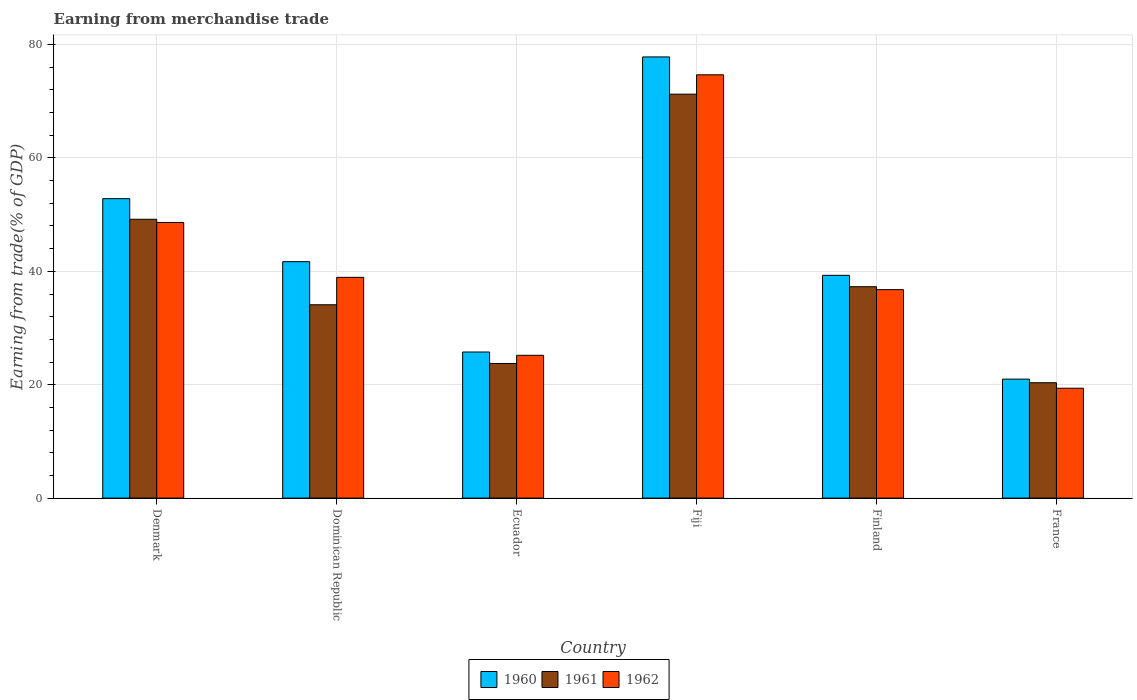How many different coloured bars are there?
Make the answer very short. 3. Are the number of bars per tick equal to the number of legend labels?
Provide a succinct answer. Yes. Are the number of bars on each tick of the X-axis equal?
Offer a terse response. Yes. How many bars are there on the 4th tick from the left?
Provide a short and direct response. 3. What is the label of the 5th group of bars from the left?
Offer a terse response. Finland. In how many cases, is the number of bars for a given country not equal to the number of legend labels?
Offer a very short reply. 0. What is the earnings from trade in 1962 in Fiji?
Offer a very short reply. 74.67. Across all countries, what is the maximum earnings from trade in 1961?
Offer a terse response. 71.25. Across all countries, what is the minimum earnings from trade in 1961?
Your response must be concise. 20.35. In which country was the earnings from trade in 1960 maximum?
Keep it short and to the point. Fiji. In which country was the earnings from trade in 1961 minimum?
Offer a very short reply. France. What is the total earnings from trade in 1961 in the graph?
Make the answer very short. 235.93. What is the difference between the earnings from trade in 1962 in Dominican Republic and that in Fiji?
Offer a terse response. -35.73. What is the difference between the earnings from trade in 1962 in Fiji and the earnings from trade in 1961 in Denmark?
Give a very brief answer. 25.48. What is the average earnings from trade in 1962 per country?
Your answer should be very brief. 40.59. What is the difference between the earnings from trade of/in 1960 and earnings from trade of/in 1961 in France?
Your answer should be compact. 0.64. What is the ratio of the earnings from trade in 1961 in Fiji to that in Finland?
Keep it short and to the point. 1.91. Is the earnings from trade in 1962 in Denmark less than that in Finland?
Provide a succinct answer. No. Is the difference between the earnings from trade in 1960 in Denmark and France greater than the difference between the earnings from trade in 1961 in Denmark and France?
Ensure brevity in your answer.  Yes. What is the difference between the highest and the second highest earnings from trade in 1960?
Give a very brief answer. -11.11. What is the difference between the highest and the lowest earnings from trade in 1960?
Give a very brief answer. 56.83. In how many countries, is the earnings from trade in 1960 greater than the average earnings from trade in 1960 taken over all countries?
Your response must be concise. 2. Is the sum of the earnings from trade in 1960 in Denmark and Fiji greater than the maximum earnings from trade in 1962 across all countries?
Provide a succinct answer. Yes. What does the 1st bar from the right in Ecuador represents?
Make the answer very short. 1962. How many bars are there?
Provide a succinct answer. 18. What is the difference between two consecutive major ticks on the Y-axis?
Provide a succinct answer. 20. Are the values on the major ticks of Y-axis written in scientific E-notation?
Your response must be concise. No. Does the graph contain any zero values?
Keep it short and to the point. No. Does the graph contain grids?
Your answer should be compact. Yes. How are the legend labels stacked?
Your answer should be compact. Horizontal. What is the title of the graph?
Offer a very short reply. Earning from merchandise trade. Does "1987" appear as one of the legend labels in the graph?
Make the answer very short. No. What is the label or title of the Y-axis?
Your answer should be compact. Earning from trade(% of GDP). What is the Earning from trade(% of GDP) in 1960 in Denmark?
Offer a very short reply. 52.82. What is the Earning from trade(% of GDP) of 1961 in Denmark?
Your answer should be very brief. 49.19. What is the Earning from trade(% of GDP) of 1962 in Denmark?
Offer a very short reply. 48.62. What is the Earning from trade(% of GDP) in 1960 in Dominican Republic?
Your response must be concise. 41.7. What is the Earning from trade(% of GDP) in 1961 in Dominican Republic?
Provide a short and direct response. 34.1. What is the Earning from trade(% of GDP) in 1962 in Dominican Republic?
Provide a succinct answer. 38.94. What is the Earning from trade(% of GDP) of 1960 in Ecuador?
Offer a very short reply. 25.77. What is the Earning from trade(% of GDP) in 1961 in Ecuador?
Ensure brevity in your answer.  23.75. What is the Earning from trade(% of GDP) in 1962 in Ecuador?
Offer a very short reply. 25.19. What is the Earning from trade(% of GDP) in 1960 in Fiji?
Your answer should be compact. 77.82. What is the Earning from trade(% of GDP) of 1961 in Fiji?
Your answer should be compact. 71.25. What is the Earning from trade(% of GDP) in 1962 in Fiji?
Your answer should be very brief. 74.67. What is the Earning from trade(% of GDP) of 1960 in Finland?
Ensure brevity in your answer.  39.29. What is the Earning from trade(% of GDP) in 1961 in Finland?
Give a very brief answer. 37.29. What is the Earning from trade(% of GDP) in 1962 in Finland?
Make the answer very short. 36.77. What is the Earning from trade(% of GDP) in 1960 in France?
Your answer should be compact. 20.99. What is the Earning from trade(% of GDP) of 1961 in France?
Give a very brief answer. 20.35. What is the Earning from trade(% of GDP) in 1962 in France?
Provide a succinct answer. 19.38. Across all countries, what is the maximum Earning from trade(% of GDP) in 1960?
Your answer should be very brief. 77.82. Across all countries, what is the maximum Earning from trade(% of GDP) in 1961?
Offer a very short reply. 71.25. Across all countries, what is the maximum Earning from trade(% of GDP) in 1962?
Ensure brevity in your answer.  74.67. Across all countries, what is the minimum Earning from trade(% of GDP) in 1960?
Keep it short and to the point. 20.99. Across all countries, what is the minimum Earning from trade(% of GDP) in 1961?
Make the answer very short. 20.35. Across all countries, what is the minimum Earning from trade(% of GDP) in 1962?
Provide a succinct answer. 19.38. What is the total Earning from trade(% of GDP) in 1960 in the graph?
Provide a short and direct response. 258.39. What is the total Earning from trade(% of GDP) of 1961 in the graph?
Give a very brief answer. 235.93. What is the total Earning from trade(% of GDP) of 1962 in the graph?
Offer a very short reply. 243.57. What is the difference between the Earning from trade(% of GDP) of 1960 in Denmark and that in Dominican Republic?
Offer a very short reply. 11.11. What is the difference between the Earning from trade(% of GDP) in 1961 in Denmark and that in Dominican Republic?
Your answer should be very brief. 15.08. What is the difference between the Earning from trade(% of GDP) of 1962 in Denmark and that in Dominican Republic?
Make the answer very short. 9.68. What is the difference between the Earning from trade(% of GDP) in 1960 in Denmark and that in Ecuador?
Ensure brevity in your answer.  27.05. What is the difference between the Earning from trade(% of GDP) in 1961 in Denmark and that in Ecuador?
Offer a terse response. 25.44. What is the difference between the Earning from trade(% of GDP) of 1962 in Denmark and that in Ecuador?
Give a very brief answer. 23.44. What is the difference between the Earning from trade(% of GDP) of 1960 in Denmark and that in Fiji?
Provide a succinct answer. -25. What is the difference between the Earning from trade(% of GDP) in 1961 in Denmark and that in Fiji?
Offer a terse response. -22.07. What is the difference between the Earning from trade(% of GDP) of 1962 in Denmark and that in Fiji?
Give a very brief answer. -26.05. What is the difference between the Earning from trade(% of GDP) of 1960 in Denmark and that in Finland?
Ensure brevity in your answer.  13.52. What is the difference between the Earning from trade(% of GDP) in 1961 in Denmark and that in Finland?
Offer a very short reply. 11.9. What is the difference between the Earning from trade(% of GDP) of 1962 in Denmark and that in Finland?
Make the answer very short. 11.85. What is the difference between the Earning from trade(% of GDP) of 1960 in Denmark and that in France?
Ensure brevity in your answer.  31.83. What is the difference between the Earning from trade(% of GDP) of 1961 in Denmark and that in France?
Keep it short and to the point. 28.84. What is the difference between the Earning from trade(% of GDP) in 1962 in Denmark and that in France?
Offer a terse response. 29.24. What is the difference between the Earning from trade(% of GDP) in 1960 in Dominican Republic and that in Ecuador?
Make the answer very short. 15.94. What is the difference between the Earning from trade(% of GDP) in 1961 in Dominican Republic and that in Ecuador?
Make the answer very short. 10.36. What is the difference between the Earning from trade(% of GDP) in 1962 in Dominican Republic and that in Ecuador?
Offer a very short reply. 13.75. What is the difference between the Earning from trade(% of GDP) of 1960 in Dominican Republic and that in Fiji?
Offer a very short reply. -36.12. What is the difference between the Earning from trade(% of GDP) in 1961 in Dominican Republic and that in Fiji?
Give a very brief answer. -37.15. What is the difference between the Earning from trade(% of GDP) of 1962 in Dominican Republic and that in Fiji?
Offer a terse response. -35.73. What is the difference between the Earning from trade(% of GDP) in 1960 in Dominican Republic and that in Finland?
Provide a succinct answer. 2.41. What is the difference between the Earning from trade(% of GDP) of 1961 in Dominican Republic and that in Finland?
Your response must be concise. -3.19. What is the difference between the Earning from trade(% of GDP) in 1962 in Dominican Republic and that in Finland?
Your answer should be very brief. 2.17. What is the difference between the Earning from trade(% of GDP) in 1960 in Dominican Republic and that in France?
Provide a succinct answer. 20.72. What is the difference between the Earning from trade(% of GDP) in 1961 in Dominican Republic and that in France?
Provide a short and direct response. 13.76. What is the difference between the Earning from trade(% of GDP) of 1962 in Dominican Republic and that in France?
Provide a succinct answer. 19.56. What is the difference between the Earning from trade(% of GDP) of 1960 in Ecuador and that in Fiji?
Your answer should be very brief. -52.05. What is the difference between the Earning from trade(% of GDP) in 1961 in Ecuador and that in Fiji?
Your answer should be compact. -47.51. What is the difference between the Earning from trade(% of GDP) of 1962 in Ecuador and that in Fiji?
Your answer should be very brief. -49.48. What is the difference between the Earning from trade(% of GDP) of 1960 in Ecuador and that in Finland?
Offer a very short reply. -13.53. What is the difference between the Earning from trade(% of GDP) in 1961 in Ecuador and that in Finland?
Offer a very short reply. -13.54. What is the difference between the Earning from trade(% of GDP) in 1962 in Ecuador and that in Finland?
Your answer should be compact. -11.59. What is the difference between the Earning from trade(% of GDP) of 1960 in Ecuador and that in France?
Give a very brief answer. 4.78. What is the difference between the Earning from trade(% of GDP) of 1961 in Ecuador and that in France?
Your answer should be compact. 3.4. What is the difference between the Earning from trade(% of GDP) of 1962 in Ecuador and that in France?
Your answer should be compact. 5.81. What is the difference between the Earning from trade(% of GDP) in 1960 in Fiji and that in Finland?
Offer a very short reply. 38.52. What is the difference between the Earning from trade(% of GDP) in 1961 in Fiji and that in Finland?
Give a very brief answer. 33.96. What is the difference between the Earning from trade(% of GDP) of 1962 in Fiji and that in Finland?
Provide a succinct answer. 37.9. What is the difference between the Earning from trade(% of GDP) of 1960 in Fiji and that in France?
Make the answer very short. 56.83. What is the difference between the Earning from trade(% of GDP) of 1961 in Fiji and that in France?
Offer a very short reply. 50.91. What is the difference between the Earning from trade(% of GDP) of 1962 in Fiji and that in France?
Your answer should be very brief. 55.29. What is the difference between the Earning from trade(% of GDP) of 1960 in Finland and that in France?
Your answer should be very brief. 18.31. What is the difference between the Earning from trade(% of GDP) in 1961 in Finland and that in France?
Give a very brief answer. 16.94. What is the difference between the Earning from trade(% of GDP) in 1962 in Finland and that in France?
Provide a short and direct response. 17.39. What is the difference between the Earning from trade(% of GDP) of 1960 in Denmark and the Earning from trade(% of GDP) of 1961 in Dominican Republic?
Provide a short and direct response. 18.72. What is the difference between the Earning from trade(% of GDP) of 1960 in Denmark and the Earning from trade(% of GDP) of 1962 in Dominican Republic?
Provide a succinct answer. 13.88. What is the difference between the Earning from trade(% of GDP) of 1961 in Denmark and the Earning from trade(% of GDP) of 1962 in Dominican Republic?
Make the answer very short. 10.25. What is the difference between the Earning from trade(% of GDP) in 1960 in Denmark and the Earning from trade(% of GDP) in 1961 in Ecuador?
Offer a very short reply. 29.07. What is the difference between the Earning from trade(% of GDP) in 1960 in Denmark and the Earning from trade(% of GDP) in 1962 in Ecuador?
Offer a very short reply. 27.63. What is the difference between the Earning from trade(% of GDP) of 1961 in Denmark and the Earning from trade(% of GDP) of 1962 in Ecuador?
Your answer should be very brief. 24. What is the difference between the Earning from trade(% of GDP) in 1960 in Denmark and the Earning from trade(% of GDP) in 1961 in Fiji?
Provide a succinct answer. -18.43. What is the difference between the Earning from trade(% of GDP) of 1960 in Denmark and the Earning from trade(% of GDP) of 1962 in Fiji?
Provide a short and direct response. -21.85. What is the difference between the Earning from trade(% of GDP) in 1961 in Denmark and the Earning from trade(% of GDP) in 1962 in Fiji?
Keep it short and to the point. -25.48. What is the difference between the Earning from trade(% of GDP) of 1960 in Denmark and the Earning from trade(% of GDP) of 1961 in Finland?
Provide a succinct answer. 15.53. What is the difference between the Earning from trade(% of GDP) in 1960 in Denmark and the Earning from trade(% of GDP) in 1962 in Finland?
Ensure brevity in your answer.  16.05. What is the difference between the Earning from trade(% of GDP) of 1961 in Denmark and the Earning from trade(% of GDP) of 1962 in Finland?
Give a very brief answer. 12.41. What is the difference between the Earning from trade(% of GDP) of 1960 in Denmark and the Earning from trade(% of GDP) of 1961 in France?
Make the answer very short. 32.47. What is the difference between the Earning from trade(% of GDP) of 1960 in Denmark and the Earning from trade(% of GDP) of 1962 in France?
Your answer should be compact. 33.44. What is the difference between the Earning from trade(% of GDP) in 1961 in Denmark and the Earning from trade(% of GDP) in 1962 in France?
Provide a short and direct response. 29.81. What is the difference between the Earning from trade(% of GDP) in 1960 in Dominican Republic and the Earning from trade(% of GDP) in 1961 in Ecuador?
Make the answer very short. 17.96. What is the difference between the Earning from trade(% of GDP) in 1960 in Dominican Republic and the Earning from trade(% of GDP) in 1962 in Ecuador?
Your answer should be very brief. 16.52. What is the difference between the Earning from trade(% of GDP) of 1961 in Dominican Republic and the Earning from trade(% of GDP) of 1962 in Ecuador?
Keep it short and to the point. 8.92. What is the difference between the Earning from trade(% of GDP) of 1960 in Dominican Republic and the Earning from trade(% of GDP) of 1961 in Fiji?
Your answer should be compact. -29.55. What is the difference between the Earning from trade(% of GDP) in 1960 in Dominican Republic and the Earning from trade(% of GDP) in 1962 in Fiji?
Provide a succinct answer. -32.96. What is the difference between the Earning from trade(% of GDP) in 1961 in Dominican Republic and the Earning from trade(% of GDP) in 1962 in Fiji?
Give a very brief answer. -40.57. What is the difference between the Earning from trade(% of GDP) of 1960 in Dominican Republic and the Earning from trade(% of GDP) of 1961 in Finland?
Your response must be concise. 4.42. What is the difference between the Earning from trade(% of GDP) of 1960 in Dominican Republic and the Earning from trade(% of GDP) of 1962 in Finland?
Give a very brief answer. 4.93. What is the difference between the Earning from trade(% of GDP) in 1961 in Dominican Republic and the Earning from trade(% of GDP) in 1962 in Finland?
Give a very brief answer. -2.67. What is the difference between the Earning from trade(% of GDP) in 1960 in Dominican Republic and the Earning from trade(% of GDP) in 1961 in France?
Provide a succinct answer. 21.36. What is the difference between the Earning from trade(% of GDP) of 1960 in Dominican Republic and the Earning from trade(% of GDP) of 1962 in France?
Ensure brevity in your answer.  22.32. What is the difference between the Earning from trade(% of GDP) in 1961 in Dominican Republic and the Earning from trade(% of GDP) in 1962 in France?
Provide a succinct answer. 14.72. What is the difference between the Earning from trade(% of GDP) in 1960 in Ecuador and the Earning from trade(% of GDP) in 1961 in Fiji?
Offer a terse response. -45.48. What is the difference between the Earning from trade(% of GDP) in 1960 in Ecuador and the Earning from trade(% of GDP) in 1962 in Fiji?
Your answer should be very brief. -48.9. What is the difference between the Earning from trade(% of GDP) in 1961 in Ecuador and the Earning from trade(% of GDP) in 1962 in Fiji?
Your answer should be compact. -50.92. What is the difference between the Earning from trade(% of GDP) in 1960 in Ecuador and the Earning from trade(% of GDP) in 1961 in Finland?
Your answer should be compact. -11.52. What is the difference between the Earning from trade(% of GDP) in 1960 in Ecuador and the Earning from trade(% of GDP) in 1962 in Finland?
Ensure brevity in your answer.  -11. What is the difference between the Earning from trade(% of GDP) in 1961 in Ecuador and the Earning from trade(% of GDP) in 1962 in Finland?
Provide a succinct answer. -13.02. What is the difference between the Earning from trade(% of GDP) of 1960 in Ecuador and the Earning from trade(% of GDP) of 1961 in France?
Your answer should be compact. 5.42. What is the difference between the Earning from trade(% of GDP) of 1960 in Ecuador and the Earning from trade(% of GDP) of 1962 in France?
Your answer should be very brief. 6.39. What is the difference between the Earning from trade(% of GDP) in 1961 in Ecuador and the Earning from trade(% of GDP) in 1962 in France?
Ensure brevity in your answer.  4.37. What is the difference between the Earning from trade(% of GDP) of 1960 in Fiji and the Earning from trade(% of GDP) of 1961 in Finland?
Your answer should be very brief. 40.53. What is the difference between the Earning from trade(% of GDP) in 1960 in Fiji and the Earning from trade(% of GDP) in 1962 in Finland?
Your answer should be compact. 41.05. What is the difference between the Earning from trade(% of GDP) of 1961 in Fiji and the Earning from trade(% of GDP) of 1962 in Finland?
Provide a succinct answer. 34.48. What is the difference between the Earning from trade(% of GDP) in 1960 in Fiji and the Earning from trade(% of GDP) in 1961 in France?
Ensure brevity in your answer.  57.47. What is the difference between the Earning from trade(% of GDP) of 1960 in Fiji and the Earning from trade(% of GDP) of 1962 in France?
Your answer should be very brief. 58.44. What is the difference between the Earning from trade(% of GDP) of 1961 in Fiji and the Earning from trade(% of GDP) of 1962 in France?
Keep it short and to the point. 51.87. What is the difference between the Earning from trade(% of GDP) in 1960 in Finland and the Earning from trade(% of GDP) in 1961 in France?
Ensure brevity in your answer.  18.95. What is the difference between the Earning from trade(% of GDP) in 1960 in Finland and the Earning from trade(% of GDP) in 1962 in France?
Your answer should be compact. 19.91. What is the difference between the Earning from trade(% of GDP) in 1961 in Finland and the Earning from trade(% of GDP) in 1962 in France?
Keep it short and to the point. 17.91. What is the average Earning from trade(% of GDP) in 1960 per country?
Offer a very short reply. 43.07. What is the average Earning from trade(% of GDP) in 1961 per country?
Provide a short and direct response. 39.32. What is the average Earning from trade(% of GDP) in 1962 per country?
Your response must be concise. 40.59. What is the difference between the Earning from trade(% of GDP) in 1960 and Earning from trade(% of GDP) in 1961 in Denmark?
Provide a succinct answer. 3.63. What is the difference between the Earning from trade(% of GDP) in 1960 and Earning from trade(% of GDP) in 1962 in Denmark?
Give a very brief answer. 4.2. What is the difference between the Earning from trade(% of GDP) of 1961 and Earning from trade(% of GDP) of 1962 in Denmark?
Your answer should be compact. 0.56. What is the difference between the Earning from trade(% of GDP) of 1960 and Earning from trade(% of GDP) of 1961 in Dominican Republic?
Provide a short and direct response. 7.6. What is the difference between the Earning from trade(% of GDP) in 1960 and Earning from trade(% of GDP) in 1962 in Dominican Republic?
Offer a very short reply. 2.77. What is the difference between the Earning from trade(% of GDP) in 1961 and Earning from trade(% of GDP) in 1962 in Dominican Republic?
Give a very brief answer. -4.84. What is the difference between the Earning from trade(% of GDP) of 1960 and Earning from trade(% of GDP) of 1961 in Ecuador?
Make the answer very short. 2.02. What is the difference between the Earning from trade(% of GDP) in 1960 and Earning from trade(% of GDP) in 1962 in Ecuador?
Make the answer very short. 0.58. What is the difference between the Earning from trade(% of GDP) of 1961 and Earning from trade(% of GDP) of 1962 in Ecuador?
Provide a short and direct response. -1.44. What is the difference between the Earning from trade(% of GDP) in 1960 and Earning from trade(% of GDP) in 1961 in Fiji?
Provide a short and direct response. 6.57. What is the difference between the Earning from trade(% of GDP) of 1960 and Earning from trade(% of GDP) of 1962 in Fiji?
Your answer should be compact. 3.15. What is the difference between the Earning from trade(% of GDP) in 1961 and Earning from trade(% of GDP) in 1962 in Fiji?
Offer a very short reply. -3.42. What is the difference between the Earning from trade(% of GDP) of 1960 and Earning from trade(% of GDP) of 1961 in Finland?
Offer a terse response. 2.01. What is the difference between the Earning from trade(% of GDP) in 1960 and Earning from trade(% of GDP) in 1962 in Finland?
Your answer should be compact. 2.52. What is the difference between the Earning from trade(% of GDP) in 1961 and Earning from trade(% of GDP) in 1962 in Finland?
Provide a succinct answer. 0.52. What is the difference between the Earning from trade(% of GDP) in 1960 and Earning from trade(% of GDP) in 1961 in France?
Your answer should be very brief. 0.64. What is the difference between the Earning from trade(% of GDP) in 1960 and Earning from trade(% of GDP) in 1962 in France?
Your answer should be very brief. 1.61. What is the difference between the Earning from trade(% of GDP) in 1961 and Earning from trade(% of GDP) in 1962 in France?
Give a very brief answer. 0.97. What is the ratio of the Earning from trade(% of GDP) in 1960 in Denmark to that in Dominican Republic?
Your answer should be compact. 1.27. What is the ratio of the Earning from trade(% of GDP) in 1961 in Denmark to that in Dominican Republic?
Provide a succinct answer. 1.44. What is the ratio of the Earning from trade(% of GDP) of 1962 in Denmark to that in Dominican Republic?
Give a very brief answer. 1.25. What is the ratio of the Earning from trade(% of GDP) in 1960 in Denmark to that in Ecuador?
Offer a terse response. 2.05. What is the ratio of the Earning from trade(% of GDP) in 1961 in Denmark to that in Ecuador?
Offer a very short reply. 2.07. What is the ratio of the Earning from trade(% of GDP) in 1962 in Denmark to that in Ecuador?
Your response must be concise. 1.93. What is the ratio of the Earning from trade(% of GDP) in 1960 in Denmark to that in Fiji?
Keep it short and to the point. 0.68. What is the ratio of the Earning from trade(% of GDP) of 1961 in Denmark to that in Fiji?
Provide a succinct answer. 0.69. What is the ratio of the Earning from trade(% of GDP) of 1962 in Denmark to that in Fiji?
Offer a very short reply. 0.65. What is the ratio of the Earning from trade(% of GDP) of 1960 in Denmark to that in Finland?
Keep it short and to the point. 1.34. What is the ratio of the Earning from trade(% of GDP) in 1961 in Denmark to that in Finland?
Keep it short and to the point. 1.32. What is the ratio of the Earning from trade(% of GDP) of 1962 in Denmark to that in Finland?
Give a very brief answer. 1.32. What is the ratio of the Earning from trade(% of GDP) of 1960 in Denmark to that in France?
Keep it short and to the point. 2.52. What is the ratio of the Earning from trade(% of GDP) in 1961 in Denmark to that in France?
Offer a very short reply. 2.42. What is the ratio of the Earning from trade(% of GDP) of 1962 in Denmark to that in France?
Your response must be concise. 2.51. What is the ratio of the Earning from trade(% of GDP) of 1960 in Dominican Republic to that in Ecuador?
Your response must be concise. 1.62. What is the ratio of the Earning from trade(% of GDP) in 1961 in Dominican Republic to that in Ecuador?
Your answer should be compact. 1.44. What is the ratio of the Earning from trade(% of GDP) of 1962 in Dominican Republic to that in Ecuador?
Make the answer very short. 1.55. What is the ratio of the Earning from trade(% of GDP) in 1960 in Dominican Republic to that in Fiji?
Ensure brevity in your answer.  0.54. What is the ratio of the Earning from trade(% of GDP) in 1961 in Dominican Republic to that in Fiji?
Provide a succinct answer. 0.48. What is the ratio of the Earning from trade(% of GDP) of 1962 in Dominican Republic to that in Fiji?
Your answer should be compact. 0.52. What is the ratio of the Earning from trade(% of GDP) in 1960 in Dominican Republic to that in Finland?
Your answer should be compact. 1.06. What is the ratio of the Earning from trade(% of GDP) in 1961 in Dominican Republic to that in Finland?
Offer a terse response. 0.91. What is the ratio of the Earning from trade(% of GDP) in 1962 in Dominican Republic to that in Finland?
Offer a very short reply. 1.06. What is the ratio of the Earning from trade(% of GDP) in 1960 in Dominican Republic to that in France?
Make the answer very short. 1.99. What is the ratio of the Earning from trade(% of GDP) of 1961 in Dominican Republic to that in France?
Keep it short and to the point. 1.68. What is the ratio of the Earning from trade(% of GDP) in 1962 in Dominican Republic to that in France?
Your response must be concise. 2.01. What is the ratio of the Earning from trade(% of GDP) of 1960 in Ecuador to that in Fiji?
Provide a short and direct response. 0.33. What is the ratio of the Earning from trade(% of GDP) in 1962 in Ecuador to that in Fiji?
Ensure brevity in your answer.  0.34. What is the ratio of the Earning from trade(% of GDP) in 1960 in Ecuador to that in Finland?
Give a very brief answer. 0.66. What is the ratio of the Earning from trade(% of GDP) in 1961 in Ecuador to that in Finland?
Make the answer very short. 0.64. What is the ratio of the Earning from trade(% of GDP) of 1962 in Ecuador to that in Finland?
Provide a succinct answer. 0.68. What is the ratio of the Earning from trade(% of GDP) in 1960 in Ecuador to that in France?
Keep it short and to the point. 1.23. What is the ratio of the Earning from trade(% of GDP) in 1961 in Ecuador to that in France?
Your answer should be compact. 1.17. What is the ratio of the Earning from trade(% of GDP) of 1962 in Ecuador to that in France?
Your response must be concise. 1.3. What is the ratio of the Earning from trade(% of GDP) in 1960 in Fiji to that in Finland?
Provide a succinct answer. 1.98. What is the ratio of the Earning from trade(% of GDP) in 1961 in Fiji to that in Finland?
Make the answer very short. 1.91. What is the ratio of the Earning from trade(% of GDP) in 1962 in Fiji to that in Finland?
Your answer should be compact. 2.03. What is the ratio of the Earning from trade(% of GDP) of 1960 in Fiji to that in France?
Offer a terse response. 3.71. What is the ratio of the Earning from trade(% of GDP) in 1961 in Fiji to that in France?
Provide a succinct answer. 3.5. What is the ratio of the Earning from trade(% of GDP) in 1962 in Fiji to that in France?
Give a very brief answer. 3.85. What is the ratio of the Earning from trade(% of GDP) in 1960 in Finland to that in France?
Provide a short and direct response. 1.87. What is the ratio of the Earning from trade(% of GDP) of 1961 in Finland to that in France?
Your answer should be compact. 1.83. What is the ratio of the Earning from trade(% of GDP) in 1962 in Finland to that in France?
Offer a terse response. 1.9. What is the difference between the highest and the second highest Earning from trade(% of GDP) in 1960?
Offer a terse response. 25. What is the difference between the highest and the second highest Earning from trade(% of GDP) in 1961?
Offer a very short reply. 22.07. What is the difference between the highest and the second highest Earning from trade(% of GDP) in 1962?
Offer a very short reply. 26.05. What is the difference between the highest and the lowest Earning from trade(% of GDP) of 1960?
Offer a very short reply. 56.83. What is the difference between the highest and the lowest Earning from trade(% of GDP) in 1961?
Your answer should be compact. 50.91. What is the difference between the highest and the lowest Earning from trade(% of GDP) in 1962?
Ensure brevity in your answer.  55.29. 